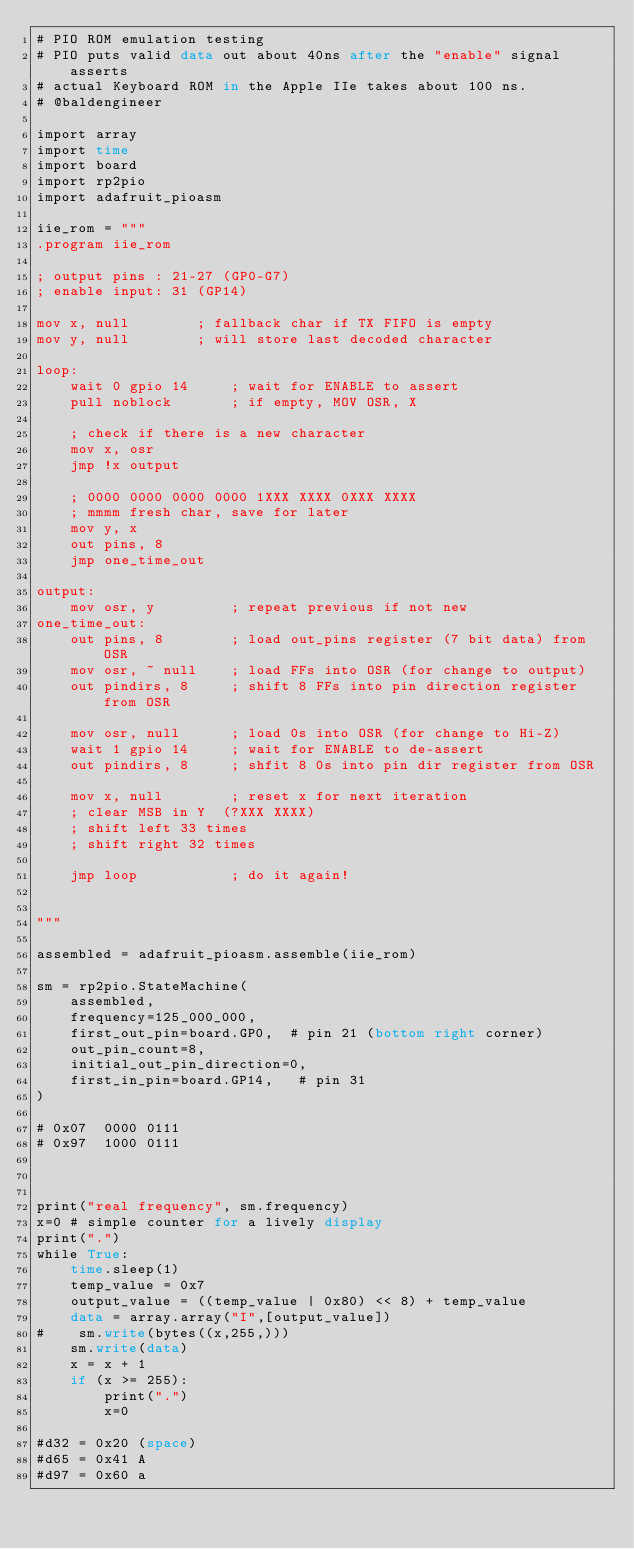<code> <loc_0><loc_0><loc_500><loc_500><_COBOL_># PIO ROM emulation testing
# PIO puts valid data out about 40ns after the "enable" signal asserts
# actual Keyboard ROM in the Apple IIe takes about 100 ns.
# @baldengineer

import array
import time
import board
import rp2pio
import adafruit_pioasm

iie_rom = """
.program iie_rom

; output pins : 21-27 (GP0-G7)
; enable input: 31 (GP14)

mov x, null        ; fallback char if TX FIFO is empty
mov y, null        ; will store last decoded character

loop:
    wait 0 gpio 14     ; wait for ENABLE to assert
    pull noblock       ; if empty, MOV OSR, X

    ; check if there is a new character
    mov x, osr
    jmp !x output      

    ; 0000 0000 0000 0000 1XXX XXXX 0XXX XXXX
    ; mmmm fresh char, save for later
    mov y, x
    out pins, 8
    jmp one_time_out

output:
    mov osr, y         ; repeat previous if not new
one_time_out:
    out pins, 8        ; load out_pins register (7 bit data) from OSR
    mov osr, ~ null    ; load FFs into OSR (for change to output)
    out pindirs, 8     ; shift 8 FFs into pin direction register from OSR

    mov osr, null      ; load 0s into OSR (for change to Hi-Z)
    wait 1 gpio 14     ; wait for ENABLE to de-assert
    out pindirs, 8     ; shfit 8 0s into pin dir register from OSR

    mov x, null        ; reset x for next iteration
    ; clear MSB in Y  (?XXX XXXX)
    ; shift left 33 times
    ; shift right 32 times

    jmp loop           ; do it again!


"""

assembled = adafruit_pioasm.assemble(iie_rom)

sm = rp2pio.StateMachine(
    assembled,
    frequency=125_000_000,
    first_out_pin=board.GP0,  # pin 21 (bottom right corner)
    out_pin_count=8,
    initial_out_pin_direction=0,
    first_in_pin=board.GP14,   # pin 31
)

# 0x07  0000 0111
# 0x97  1000 0111



print("real frequency", sm.frequency)
x=0 # simple counter for a lively display
print(".")
while True:
    time.sleep(1)
    temp_value = 0x7
    output_value = ((temp_value | 0x80) << 8) + temp_value
    data = array.array("I",[output_value])
#    sm.write(bytes((x,255,)))
    sm.write(data)
    x = x + 1
    if (x >= 255):
        print(".")
        x=0

#d32 = 0x20 (space)
#d65 = 0x41 A
#d97 = 0x60 a
</code> 